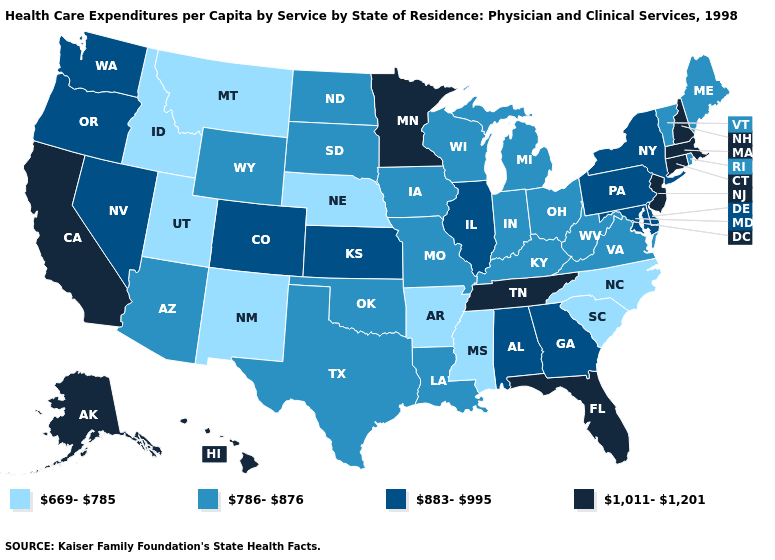Among the states that border Utah , does Nevada have the highest value?
Be succinct. Yes. Does the map have missing data?
Concise answer only. No. Does Maine have the lowest value in the Northeast?
Short answer required. Yes. What is the value of Maine?
Keep it brief. 786-876. What is the highest value in the USA?
Keep it brief. 1,011-1,201. Which states have the highest value in the USA?
Quick response, please. Alaska, California, Connecticut, Florida, Hawaii, Massachusetts, Minnesota, New Hampshire, New Jersey, Tennessee. Which states have the lowest value in the USA?
Give a very brief answer. Arkansas, Idaho, Mississippi, Montana, Nebraska, New Mexico, North Carolina, South Carolina, Utah. Does South Carolina have the lowest value in the USA?
Quick response, please. Yes. Does Florida have the highest value in the South?
Give a very brief answer. Yes. Which states have the lowest value in the West?
Concise answer only. Idaho, Montana, New Mexico, Utah. Which states hav the highest value in the West?
Give a very brief answer. Alaska, California, Hawaii. Among the states that border South Carolina , which have the highest value?
Answer briefly. Georgia. How many symbols are there in the legend?
Concise answer only. 4. Name the states that have a value in the range 786-876?
Write a very short answer. Arizona, Indiana, Iowa, Kentucky, Louisiana, Maine, Michigan, Missouri, North Dakota, Ohio, Oklahoma, Rhode Island, South Dakota, Texas, Vermont, Virginia, West Virginia, Wisconsin, Wyoming. Name the states that have a value in the range 883-995?
Write a very short answer. Alabama, Colorado, Delaware, Georgia, Illinois, Kansas, Maryland, Nevada, New York, Oregon, Pennsylvania, Washington. 